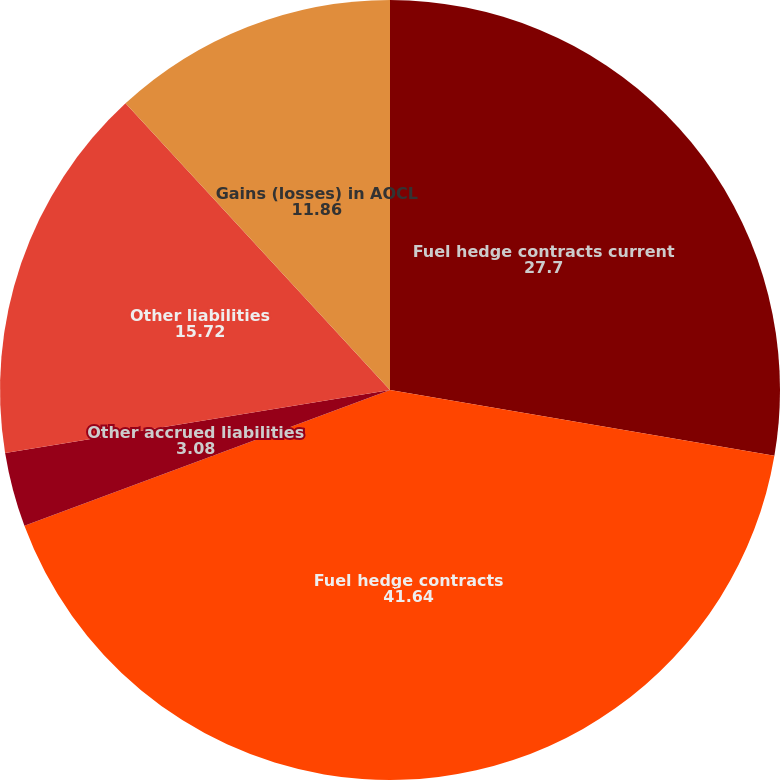Convert chart to OTSL. <chart><loc_0><loc_0><loc_500><loc_500><pie_chart><fcel>Fuel hedge contracts current<fcel>Fuel hedge contracts<fcel>Other accrued liabilities<fcel>Other liabilities<fcel>Gains (losses) in AOCL<nl><fcel>27.7%<fcel>41.64%<fcel>3.08%<fcel>15.72%<fcel>11.86%<nl></chart> 